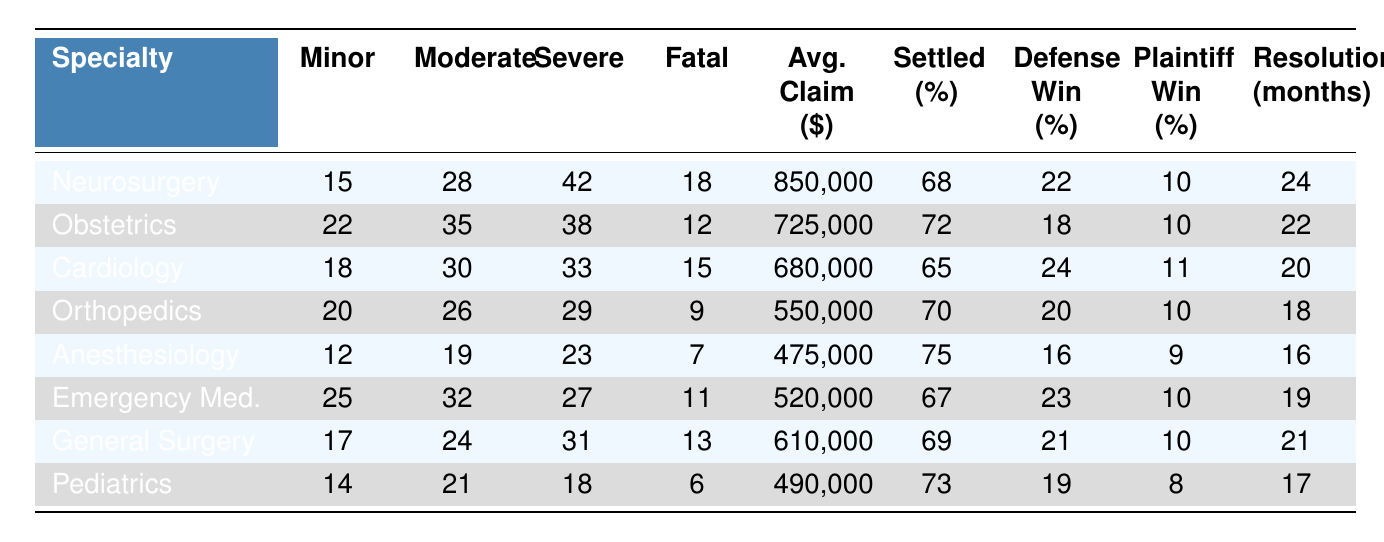What medical specialty has the highest number of severe errors? By looking at the "Severe Errors" column, we see that Neurosurgery has 42 severe errors, which is the highest among all the specialties listed.
Answer: Neurosurgery What is the average claim amount for Anesthesiology? The table indicates that the average claim amount for Anesthesiology is $475,000 as stated in the "Average Claim Amount ($)" column.
Answer: $475,000 Which specialty has the highest percentage of settled cases? The "Cases Settled (%)" column shows that Anesthesiology has the highest percentage of cases settled at 75%.
Answer: Anesthesiology Calculate the total number of minor errors across all specialties. Adding the minor errors: 15 + 22 + 18 + 20 + 12 + 25 + 17 + 14 =  153 total minor errors across all specialties.
Answer: 153 What percentage of cases are won by plaintiffs in Pediatrics? The table shows that in Pediatrics, the percentage of cases won by plaintiffs is 8%, as indicated in the "Cases Won by Plaintiff (%)" column.
Answer: 8% Is it true that Cardiology has more fatal errors than Orthopedics? In the "Fatal Errors" column, Cardiology has 15 fatal errors while Orthopedics has 9. Therefore, it is true that Cardiology has more fatal errors.
Answer: Yes Which specialty has both the lowest average claim amount and the lowest percentage of cases won by plaintiffs? Reviewing the "Average Claim Amount ($)" and "Cases Won by Plaintiff (%)", we see that Anesthesiology has the lowest average claim amount of $475,000 and the lowest percentage of cases won by plaintiffs at 9%.
Answer: Anesthesiology How does the average time to resolution in Emergency Medicine compare to that in Neurosurgery? Emergency Medicine has an average resolution time of 19 months, while Neurosurgery has a time of 24 months. Thus, Emergency Medicine has a shorter resolution time by 5 months.
Answer: 5 months shorter What specialty has the highest number of minor errors and what is the settlement percentage for that specialty? The highest number of minor errors is in Emergency Medicine with 25. The settlement percentage for Emergency Medicine is 67%, as shown in the respective columns.
Answer: 25 errors and 67% settled Calculate the difference in percentage of cases won by defense between Obstetrics and Pediatrics. Obstetrics has 18% of cases won by defense, and Pediatrics has 19%. The difference is 19 - 18 = 1%.
Answer: 1% 